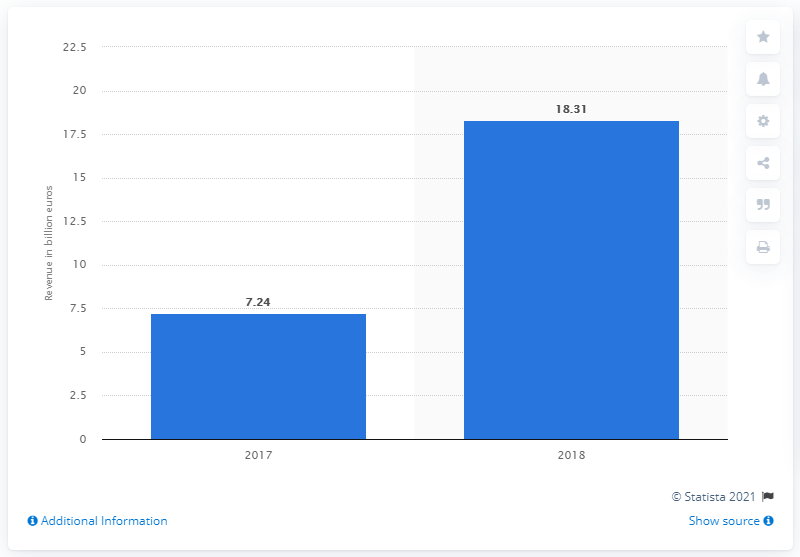Identify some key points in this picture. In 2018, Opel/Vauxhall generated a revenue of 18.31 billion USD. 